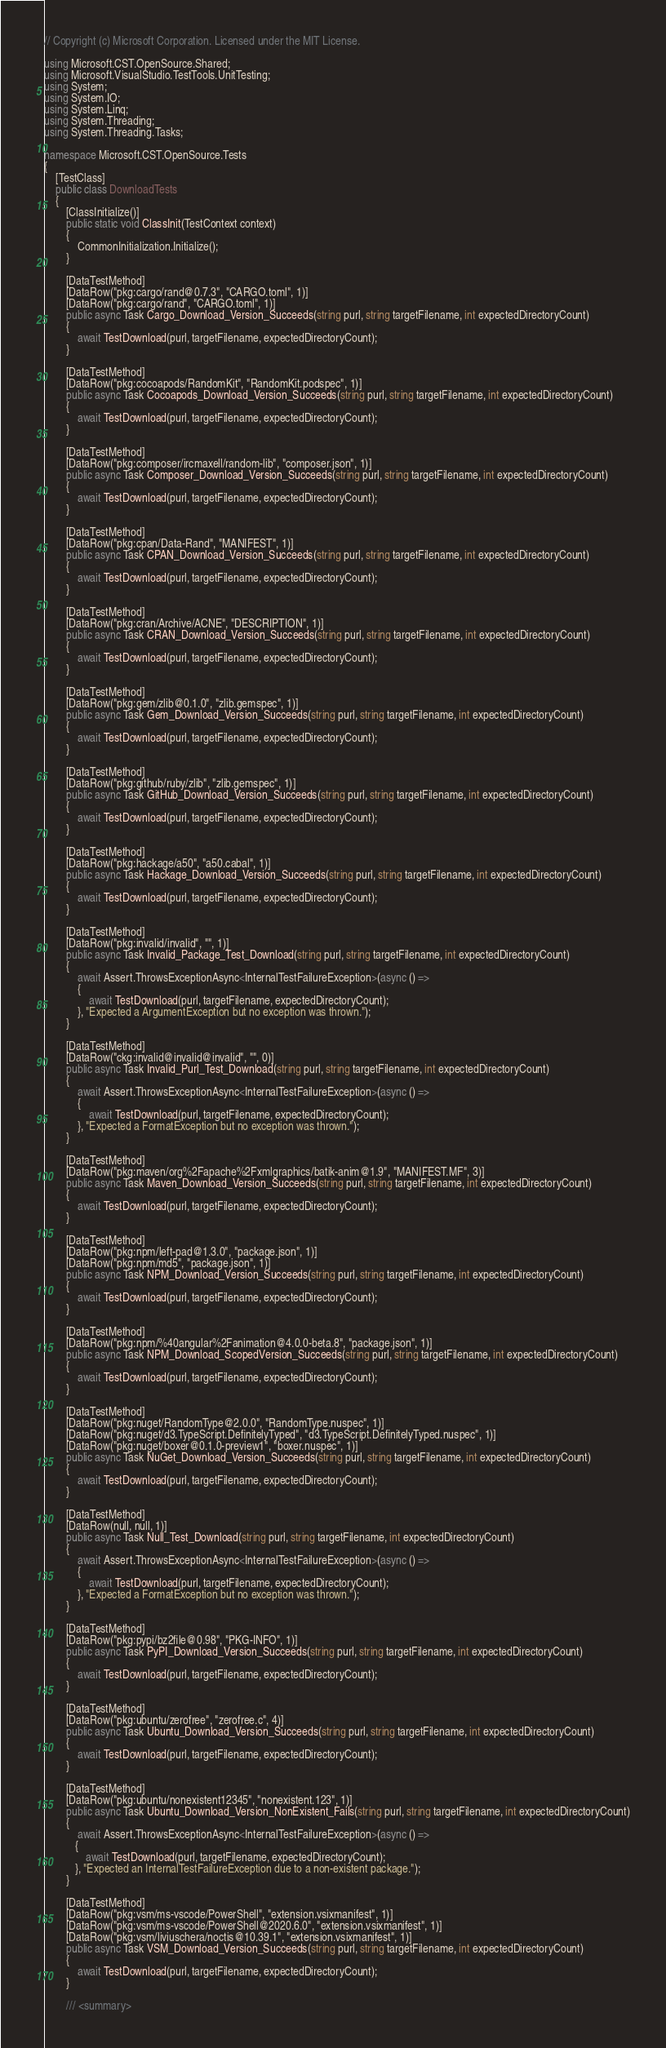<code> <loc_0><loc_0><loc_500><loc_500><_C#_>// Copyright (c) Microsoft Corporation. Licensed under the MIT License.

using Microsoft.CST.OpenSource.Shared;
using Microsoft.VisualStudio.TestTools.UnitTesting;
using System;
using System.IO;
using System.Linq;
using System.Threading;
using System.Threading.Tasks;

namespace Microsoft.CST.OpenSource.Tests
{
    [TestClass]
    public class DownloadTests
    {
        [ClassInitialize()]
        public static void ClassInit(TestContext context)
        {
            CommonInitialization.Initialize();
        }

        [DataTestMethod]
        [DataRow("pkg:cargo/rand@0.7.3", "CARGO.toml", 1)]
        [DataRow("pkg:cargo/rand", "CARGO.toml", 1)]
        public async Task Cargo_Download_Version_Succeeds(string purl, string targetFilename, int expectedDirectoryCount)
        {
            await TestDownload(purl, targetFilename, expectedDirectoryCount);
        }

        [DataTestMethod]
        [DataRow("pkg:cocoapods/RandomKit", "RandomKit.podspec", 1)]
        public async Task Cocoapods_Download_Version_Succeeds(string purl, string targetFilename, int expectedDirectoryCount)
        {
            await TestDownload(purl, targetFilename, expectedDirectoryCount);
        }

        [DataTestMethod]
        [DataRow("pkg:composer/ircmaxell/random-lib", "composer.json", 1)]
        public async Task Composer_Download_Version_Succeeds(string purl, string targetFilename, int expectedDirectoryCount)
        {
            await TestDownload(purl, targetFilename, expectedDirectoryCount);
        }

        [DataTestMethod]
        [DataRow("pkg:cpan/Data-Rand", "MANIFEST", 1)]
        public async Task CPAN_Download_Version_Succeeds(string purl, string targetFilename, int expectedDirectoryCount)
        {
            await TestDownload(purl, targetFilename, expectedDirectoryCount);
        }

        [DataTestMethod]
        [DataRow("pkg:cran/Archive/ACNE", "DESCRIPTION", 1)]
        public async Task CRAN_Download_Version_Succeeds(string purl, string targetFilename, int expectedDirectoryCount)
        {
            await TestDownload(purl, targetFilename, expectedDirectoryCount);
        }

        [DataTestMethod]
        [DataRow("pkg:gem/zlib@0.1.0", "zlib.gemspec", 1)]
        public async Task Gem_Download_Version_Succeeds(string purl, string targetFilename, int expectedDirectoryCount)
        {
            await TestDownload(purl, targetFilename, expectedDirectoryCount);
        }

        [DataTestMethod]
        [DataRow("pkg:github/ruby/zlib", "zlib.gemspec", 1)]
        public async Task GitHub_Download_Version_Succeeds(string purl, string targetFilename, int expectedDirectoryCount)
        {
            await TestDownload(purl, targetFilename, expectedDirectoryCount);
        }

        [DataTestMethod]
        [DataRow("pkg:hackage/a50", "a50.cabal", 1)]
        public async Task Hackage_Download_Version_Succeeds(string purl, string targetFilename, int expectedDirectoryCount)
        {
            await TestDownload(purl, targetFilename, expectedDirectoryCount);
        }

        [DataTestMethod]
        [DataRow("pkg:invalid/invalid", "", 1)]
        public async Task Invalid_Package_Test_Download(string purl, string targetFilename, int expectedDirectoryCount)
        {
            await Assert.ThrowsExceptionAsync<InternalTestFailureException>(async () =>
            {
                await TestDownload(purl, targetFilename, expectedDirectoryCount);
            }, "Expected a ArgumentException but no exception was thrown.");
        }

        [DataTestMethod]
        [DataRow("ckg:invalid@invalid@invalid", "", 0)]
        public async Task Invalid_Purl_Test_Download(string purl, string targetFilename, int expectedDirectoryCount)
        {
            await Assert.ThrowsExceptionAsync<InternalTestFailureException>(async () =>
            {
                await TestDownload(purl, targetFilename, expectedDirectoryCount);
            }, "Expected a FormatException but no exception was thrown.");
        }

        [DataTestMethod]
        [DataRow("pkg:maven/org%2Fapache%2Fxmlgraphics/batik-anim@1.9", "MANIFEST.MF", 3)]
        public async Task Maven_Download_Version_Succeeds(string purl, string targetFilename, int expectedDirectoryCount)
        {
            await TestDownload(purl, targetFilename, expectedDirectoryCount);
        }

        [DataTestMethod]
        [DataRow("pkg:npm/left-pad@1.3.0", "package.json", 1)]
        [DataRow("pkg:npm/md5", "package.json", 1)]
        public async Task NPM_Download_Version_Succeeds(string purl, string targetFilename, int expectedDirectoryCount)
        {
            await TestDownload(purl, targetFilename, expectedDirectoryCount);
        }

        [DataTestMethod]
        [DataRow("pkg:npm/%40angular%2Fanimation@4.0.0-beta.8", "package.json", 1)]
        public async Task NPM_Download_ScopedVersion_Succeeds(string purl, string targetFilename, int expectedDirectoryCount)
        {
            await TestDownload(purl, targetFilename, expectedDirectoryCount);
        }

        [DataTestMethod]
        [DataRow("pkg:nuget/RandomType@2.0.0", "RandomType.nuspec", 1)]
        [DataRow("pkg:nuget/d3.TypeScript.DefinitelyTyped", "d3.TypeScript.DefinitelyTyped.nuspec", 1)]
        [DataRow("pkg:nuget/boxer@0.1.0-preview1", "boxer.nuspec", 1)]
        public async Task NuGet_Download_Version_Succeeds(string purl, string targetFilename, int expectedDirectoryCount)
        {
            await TestDownload(purl, targetFilename, expectedDirectoryCount);
        }

        [DataTestMethod]
        [DataRow(null, null, 1)]
        public async Task Null_Test_Download(string purl, string targetFilename, int expectedDirectoryCount)
        {
            await Assert.ThrowsExceptionAsync<InternalTestFailureException>(async () =>
            {
                await TestDownload(purl, targetFilename, expectedDirectoryCount);
            }, "Expected a FormatException but no exception was thrown.");
        }

        [DataTestMethod]
        [DataRow("pkg:pypi/bz2file@0.98", "PKG-INFO", 1)]
        public async Task PyPI_Download_Version_Succeeds(string purl, string targetFilename, int expectedDirectoryCount)
        {
            await TestDownload(purl, targetFilename, expectedDirectoryCount);
        }

        [DataTestMethod]
        [DataRow("pkg:ubuntu/zerofree", "zerofree.c", 4)]
        public async Task Ubuntu_Download_Version_Succeeds(string purl, string targetFilename, int expectedDirectoryCount)
        {
            await TestDownload(purl, targetFilename, expectedDirectoryCount);
        }

        [DataTestMethod]
        [DataRow("pkg:ubuntu/nonexistent12345", "nonexistent.123", 1)]
        public async Task Ubuntu_Download_Version_NonExistent_Fails(string purl, string targetFilename, int expectedDirectoryCount)
        {
            await Assert.ThrowsExceptionAsync<InternalTestFailureException>(async () =>
           {
               await TestDownload(purl, targetFilename, expectedDirectoryCount);
           }, "Expected an InternalTestFailureException due to a non-existent package.");
        }

        [DataTestMethod]
        [DataRow("pkg:vsm/ms-vscode/PowerShell", "extension.vsixmanifest", 1)]
        [DataRow("pkg:vsm/ms-vscode/PowerShell@2020.6.0", "extension.vsixmanifest", 1)]
        [DataRow("pkg:vsm/liviuschera/noctis@10.39.1", "extension.vsixmanifest", 1)]
        public async Task VSM_Download_Version_Succeeds(string purl, string targetFilename, int expectedDirectoryCount)
        {
            await TestDownload(purl, targetFilename, expectedDirectoryCount);
        }

        /// <summary></code> 